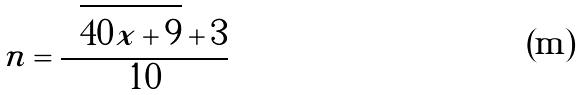<formula> <loc_0><loc_0><loc_500><loc_500>n = \frac { \sqrt { 4 0 x + 9 } + 3 } { 1 0 }</formula> 